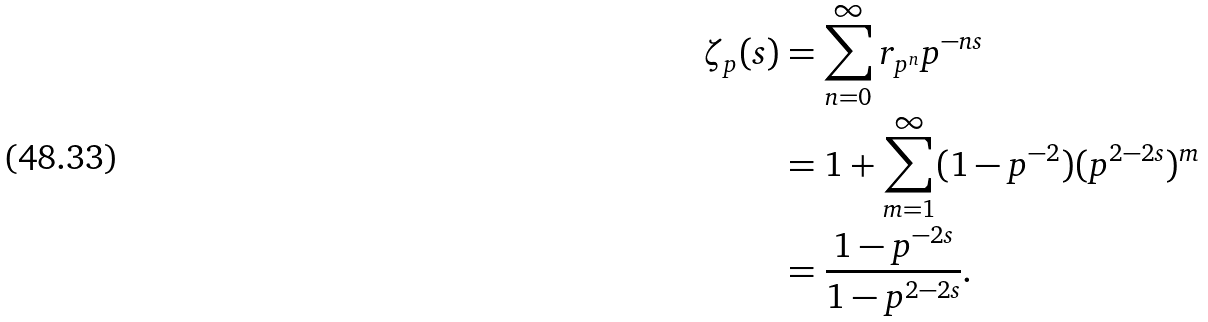<formula> <loc_0><loc_0><loc_500><loc_500>\zeta _ { p } ( s ) & = \sum _ { n = 0 } ^ { \infty } r _ { p ^ { n } } p ^ { - n s } \\ & = 1 + \sum _ { m = 1 } ^ { \infty } ( 1 - p ^ { - 2 } ) ( p ^ { 2 - 2 s } ) ^ { m } \\ & = \frac { 1 - p ^ { - 2 s } } { 1 - p ^ { 2 - 2 s } } .</formula> 